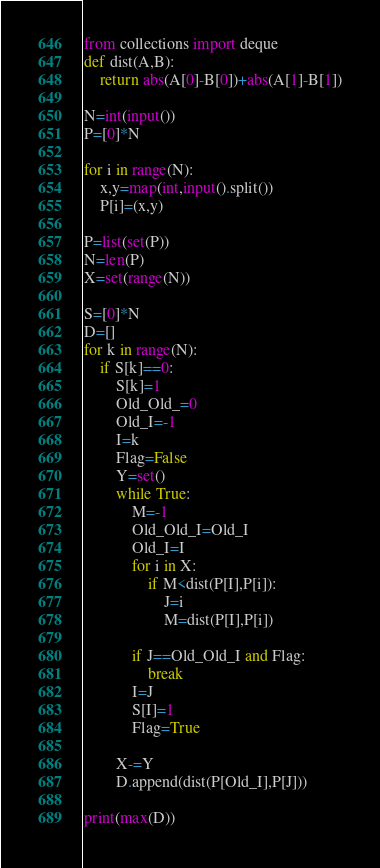<code> <loc_0><loc_0><loc_500><loc_500><_Python_>from collections import deque
def dist(A,B):
    return abs(A[0]-B[0])+abs(A[1]-B[1])

N=int(input())
P=[0]*N

for i in range(N):
    x,y=map(int,input().split())
    P[i]=(x,y)

P=list(set(P))
N=len(P)
X=set(range(N))

S=[0]*N
D=[]
for k in range(N):
    if S[k]==0:
        S[k]=1
        Old_Old_=0
        Old_I=-1
        I=k
        Flag=False
        Y=set()
        while True:
            M=-1
            Old_Old_I=Old_I
            Old_I=I
            for i in X:
                if M<dist(P[I],P[i]):
                    J=i
                    M=dist(P[I],P[i])

            if J==Old_Old_I and Flag:
                break
            I=J
            S[I]=1
            Flag=True

        X-=Y
        D.append(dist(P[Old_I],P[J]))

print(max(D))</code> 